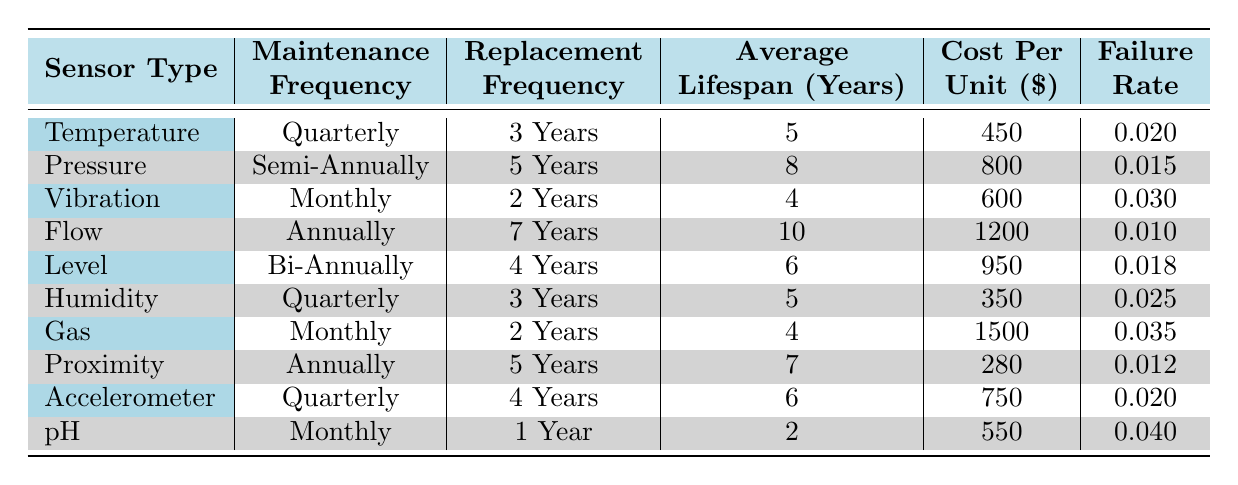What is the maintenance frequency of the Vibration sensor? The table lists the maintenance frequency for each sensor type. For the Vibration sensor, the maintenance frequency is stated directly as "Monthly."
Answer: Monthly Which sensor has the longest replacement frequency and what is that frequency? By examining the replacement frequency for each sensor, we find that the Pressure sensor has the longest replacement frequency listed as "5 Years."
Answer: 5 Years Is the cost per unit of the Gas sensor higher than the cost per unit of the Flow sensor? From the table, the cost per unit of the Gas sensor is $1500 and for the Flow sensor, it is $1200. Comparing these values shows that the Gas sensor's cost is higher.
Answer: Yes What is the average lifespan of all the sensors combined? The average lifespan can be calculated by adding the lifespans of each sensor: (5 + 8 + 4 + 10 + 6 + 5 + 4 + 7 + 6 + 2) = 57. There are 10 sensors, so the average is 57/10 = 5.7 years.
Answer: 5.7 years Are there more sensors that require quarterly maintenance than sensors that require monthly maintenance? Looking at the maintenance frequency, there are three sensors that require quarterly maintenance (Temperature, Humidity, Accelerometer) and three sensors that require monthly maintenance (Vibration, Gas, pH). Since the counts are equal, the answer is no.
Answer: No Which sensor type has the lowest failure rate and what is that rate? The table shows the failure rates for all sensors. The Proximity sensor has the lowest failure rate listed as 0.012.
Answer: 0.012 How much would it cost to replace the Humidity sensor and the Pressure sensor together? To find the total cost of replacing both sensors, we add their costs: Humidity sensor cost is $350, and Pressure sensor cost is $800. The total replacement cost is $350 + $800 = $1150.
Answer: $1150 What is the ratio of the maximum to the minimum cost per unit among the sensors listed? The maximum cost per unit is $1500 (Gas sensor) and the minimum is $280 (Proximity sensor). The ratio is calculated as 1500/280, which simplifies to approximately 5.36.
Answer: 5.36 How many sensors have an average lifespan of at least 6 years? By checking the average lifespan for each sensor, we see that the Flow (10), Pressure (8), Level (6), and Proximity (7) sensors meet this criterion. Therefore, there are four sensors with an average lifespan of at least 6 years.
Answer: 4 